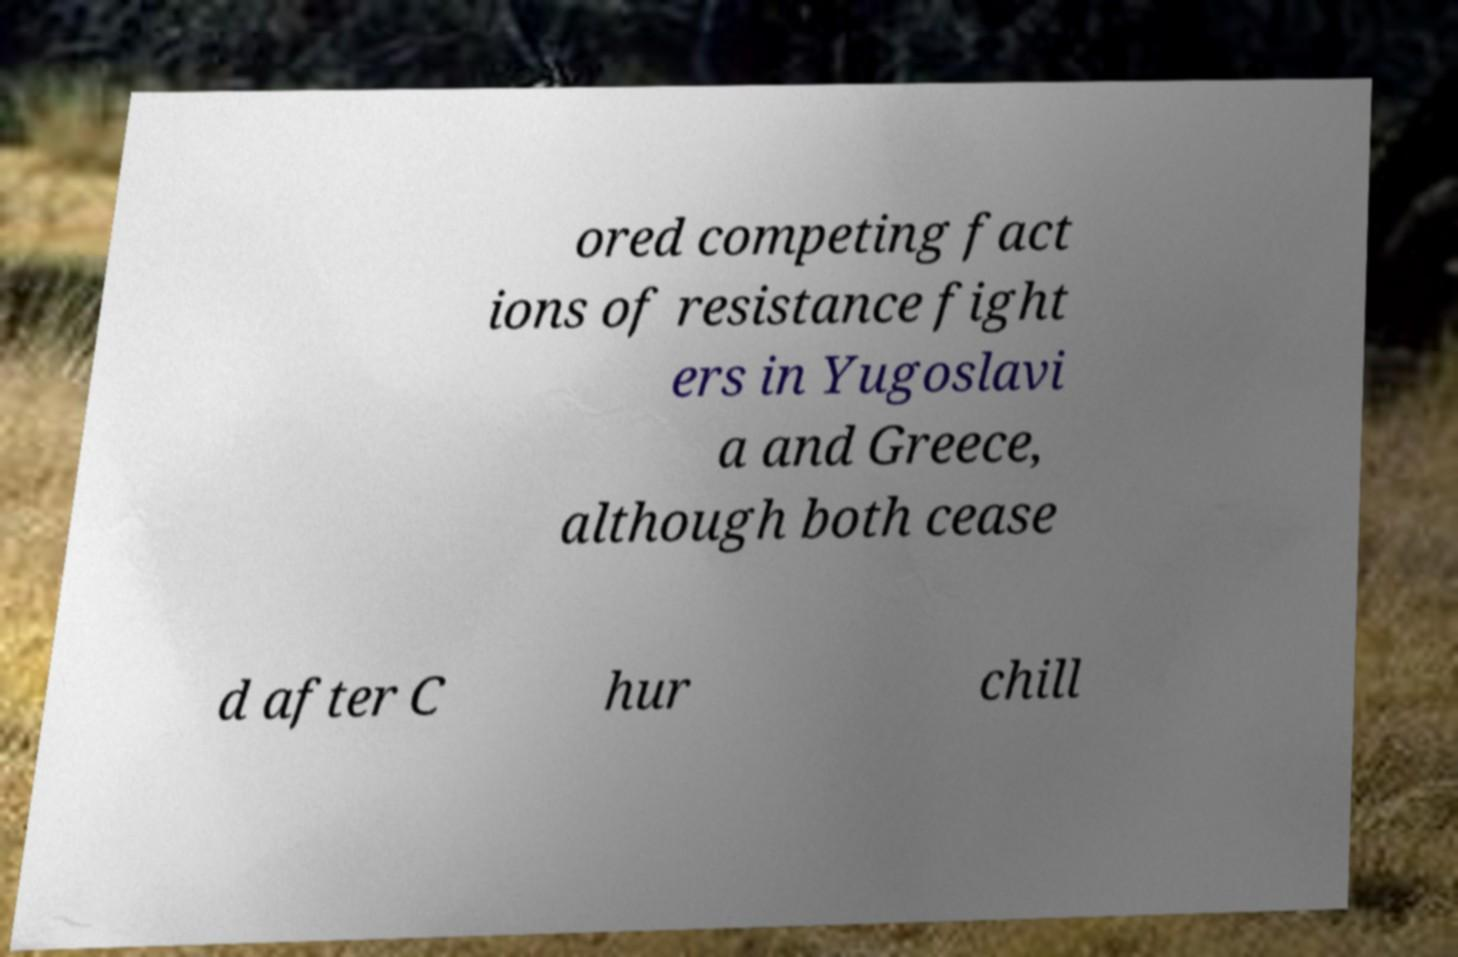What messages or text are displayed in this image? I need them in a readable, typed format. ored competing fact ions of resistance fight ers in Yugoslavi a and Greece, although both cease d after C hur chill 